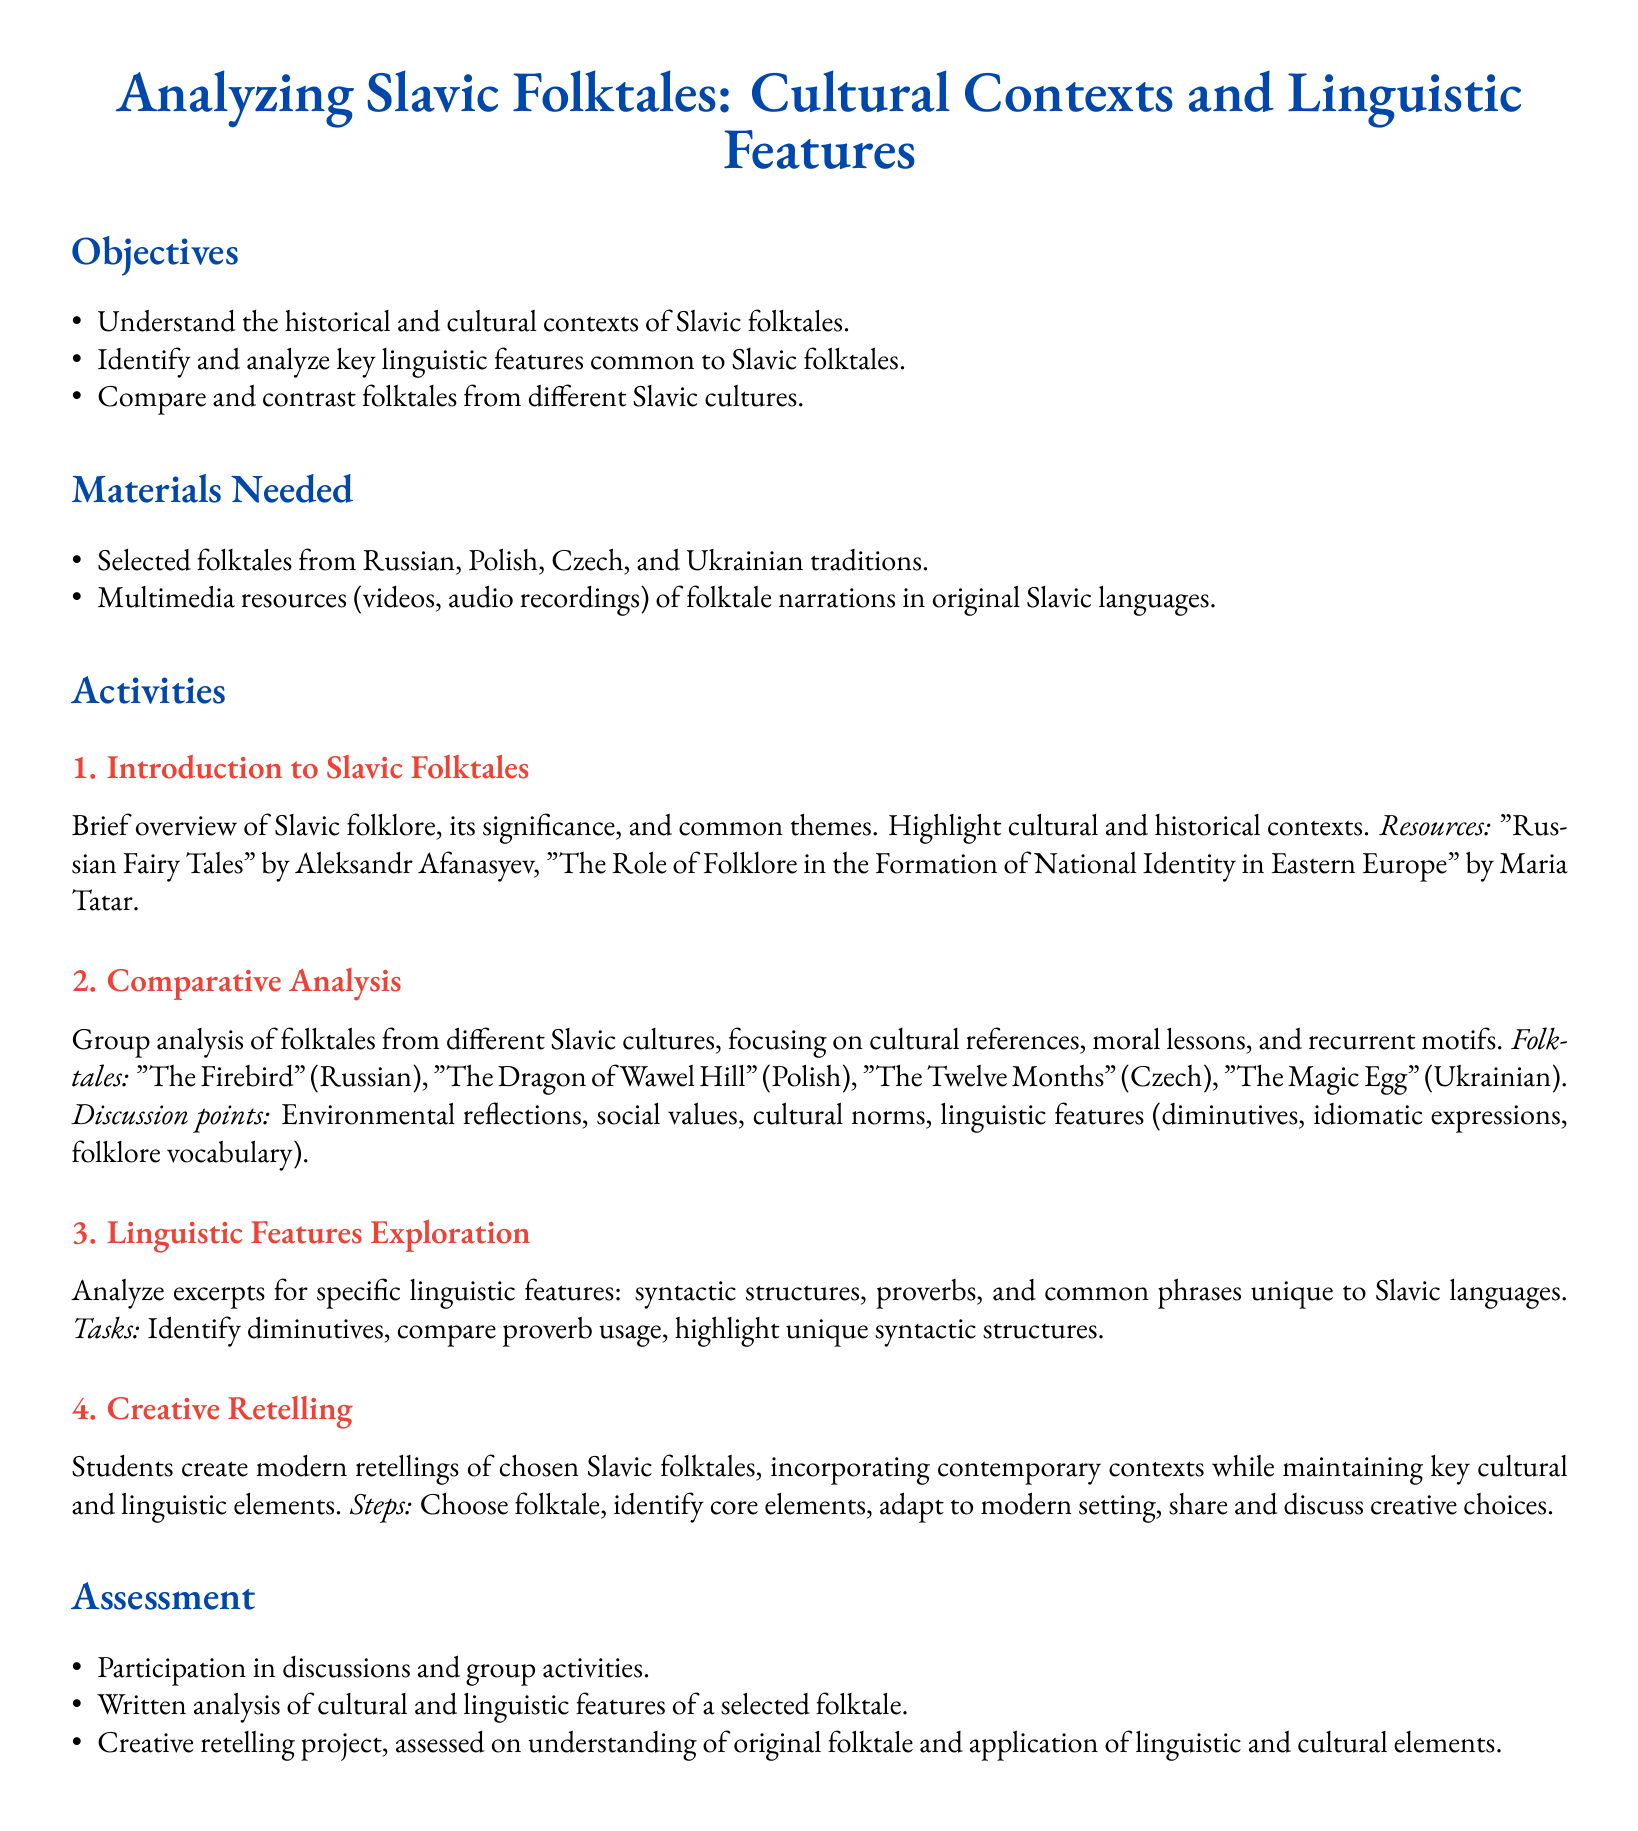what is the title of the lesson plan? The title is prominently displayed at the top of the document, indicating the subject of the lesson.
Answer: Analyzing Slavic Folktales: Cultural Contexts and Linguistic Features what is the first objective of the lesson plan? The objectives are listed in a section, specifying what students are expected to understand by the end of the lesson.
Answer: Understand the historical and cultural contexts of Slavic folktales which folktale is considered Polish? The document includes a section with enumerated folktales linked to their respective cultures.
Answer: The Dragon of Wawel Hill how many main activities are outlined in the lesson plan? The activities section lists various tasks that guide the learning process, providing an overall count of specific activities.
Answer: 4 what type of project do students create in the lesson plan? The final activity describes a creative task that students will undertake as part of their assessment process.
Answer: Creative retelling what resources are suggested for the introduction to Slavic folktales? The resources are specified in the activities section to support the learning process, indicating relevant readings.
Answer: "Russian Fairy Tales" by Aleksandr Afanasyev, "The Role of Folklore in the Formation of National Identity in Eastern Europe" by Maria Tatar which languages are the folktale narrations provided in? The materials needed section specifies the original languages for the audio and video resources.
Answer: Original Slavic languages what are the assessment criteria for the creative retelling project? The assessment criteria are listed to outline how students' work will be evaluated based on specified elements.
Answer: Understanding of original folktale and application of linguistic and cultural elements 